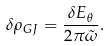<formula> <loc_0><loc_0><loc_500><loc_500>\delta \rho _ { G J } = \frac { \delta E _ { \theta } } { 2 \pi \tilde { \omega } } .</formula> 